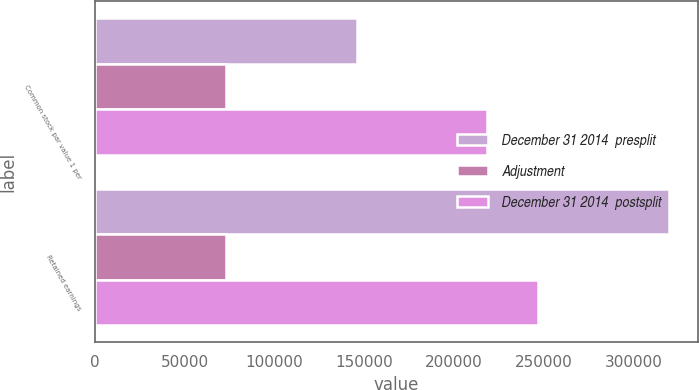<chart> <loc_0><loc_0><loc_500><loc_500><stacked_bar_chart><ecel><fcel>Common stock par value 1 per<fcel>Retained earnings<nl><fcel>December 31 2014  presplit<fcel>145722<fcel>319803<nl><fcel>Adjustment<fcel>72761<fcel>72761<nl><fcel>December 31 2014  postsplit<fcel>218483<fcel>247042<nl></chart> 